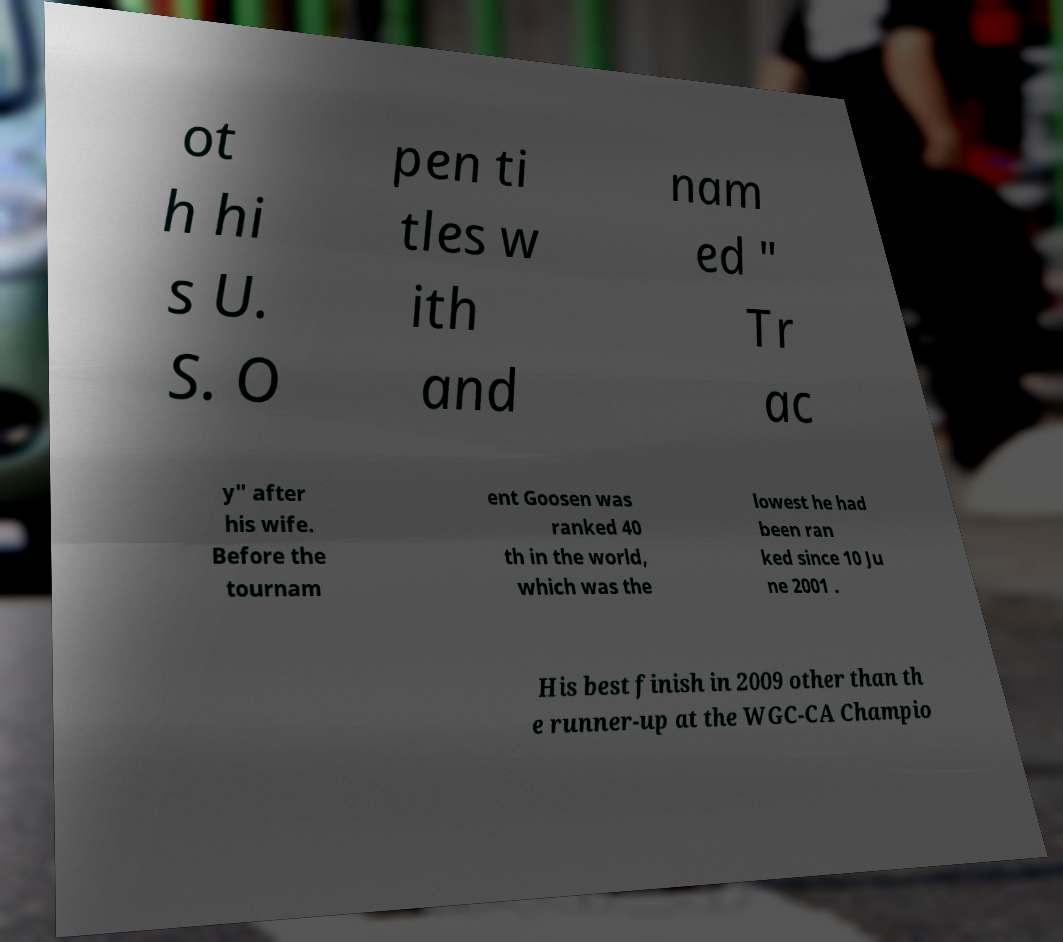Please read and relay the text visible in this image. What does it say? ot h hi s U. S. O pen ti tles w ith and nam ed " Tr ac y" after his wife. Before the tournam ent Goosen was ranked 40 th in the world, which was the lowest he had been ran ked since 10 Ju ne 2001 . His best finish in 2009 other than th e runner-up at the WGC-CA Champio 